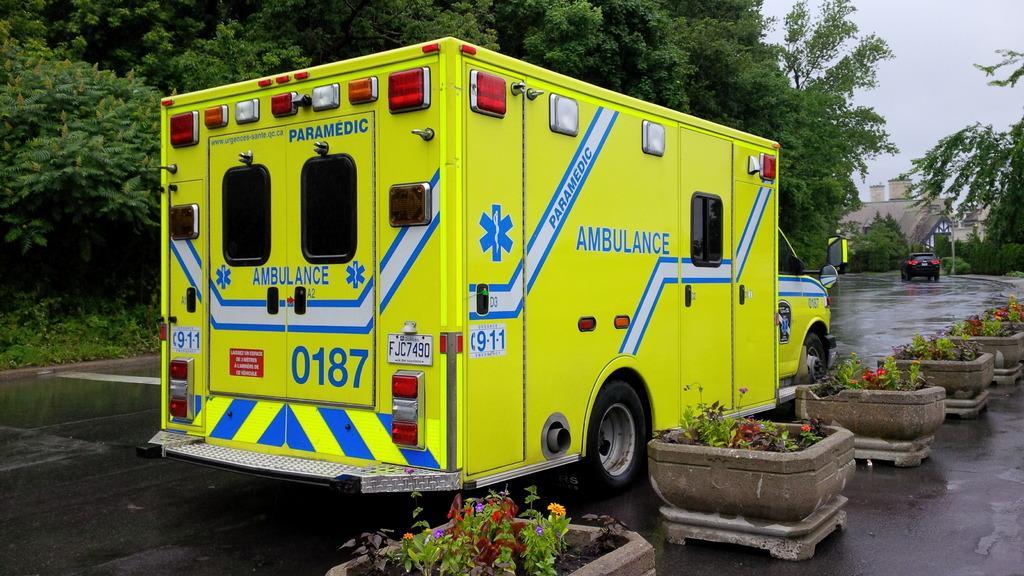How would you summarize this image in a sentence or two? In this image we can see motor vehicles on the road, house plants, trees, buildings and sky. 